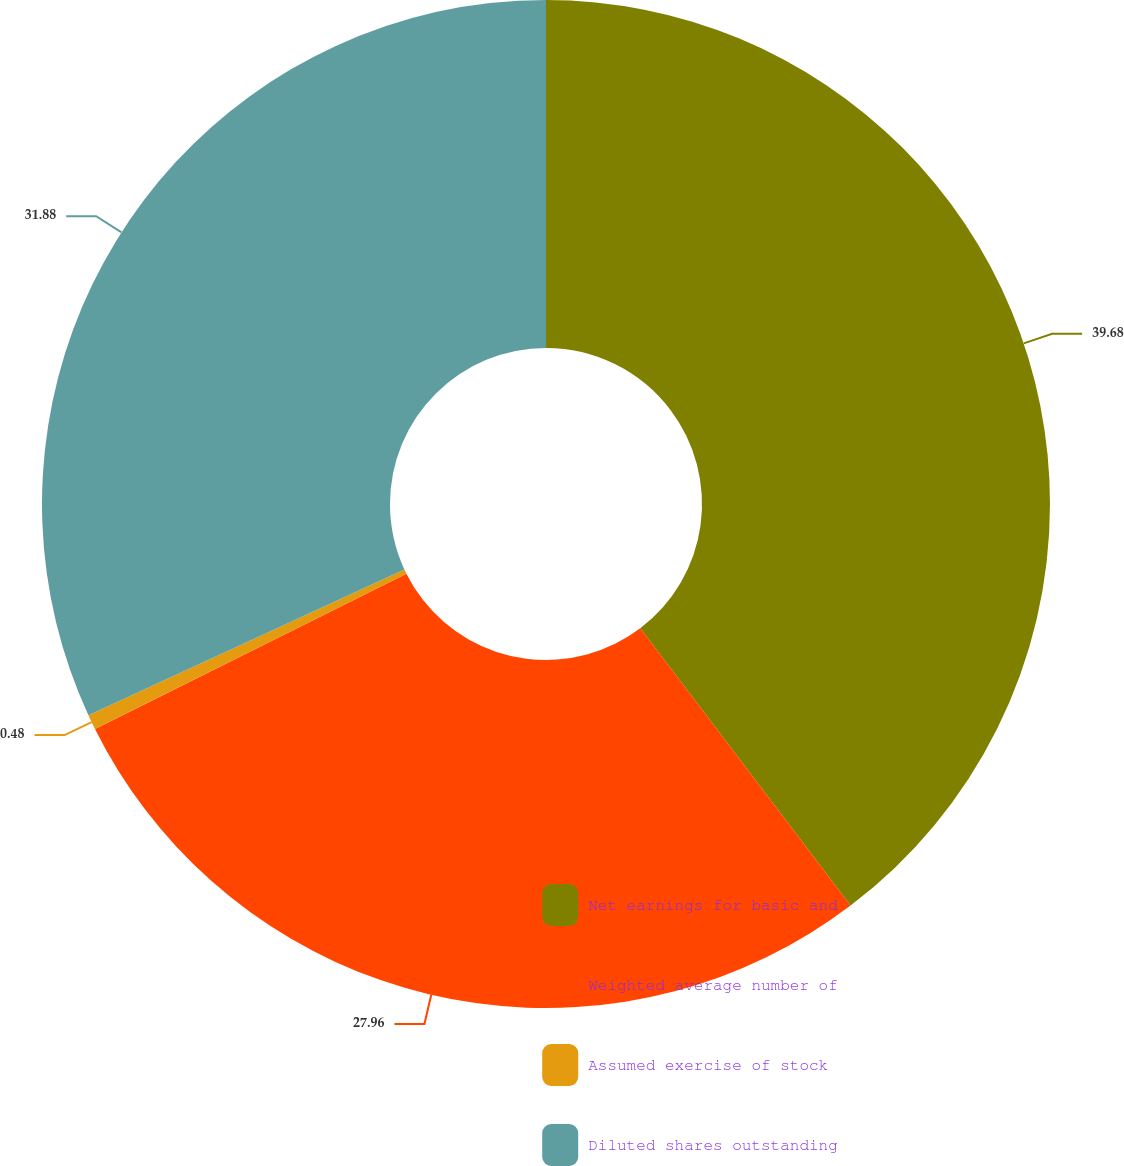Convert chart to OTSL. <chart><loc_0><loc_0><loc_500><loc_500><pie_chart><fcel>Net earnings for basic and<fcel>Weighted average number of<fcel>Assumed exercise of stock<fcel>Diluted shares outstanding<nl><fcel>39.67%<fcel>27.96%<fcel>0.48%<fcel>31.88%<nl></chart> 